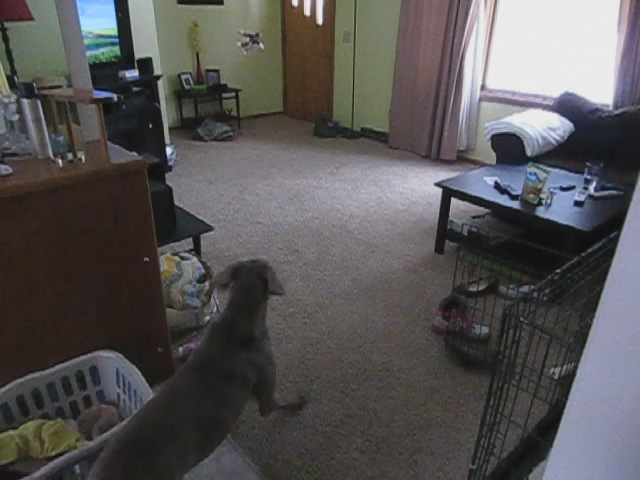<image>What type of stuffed animal in on the floor? It is ambiguous to determine the type of stuffed animal on the floor. It could be a cat, a bear, a teddy bear, a dog or there might be none. What type of stuffed animal in on the floor? I am not sure what type of stuffed animal is on the floor. It can be seen 'cat', 'bear', 'teddy bear' or 'dog'. 